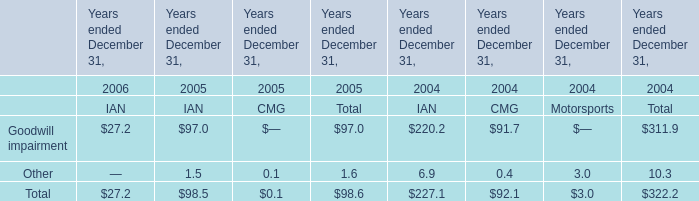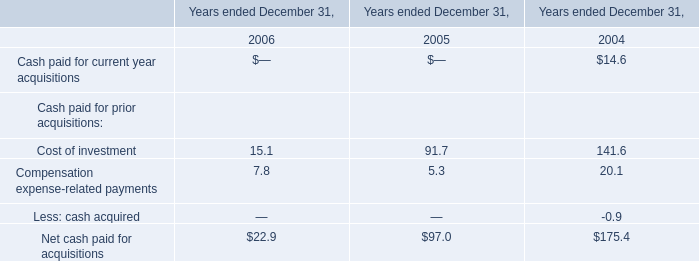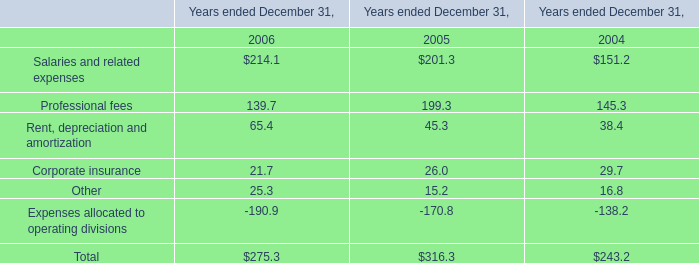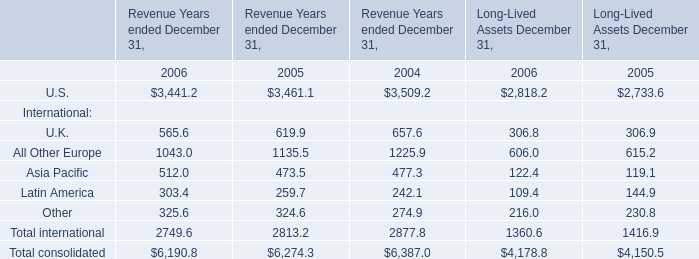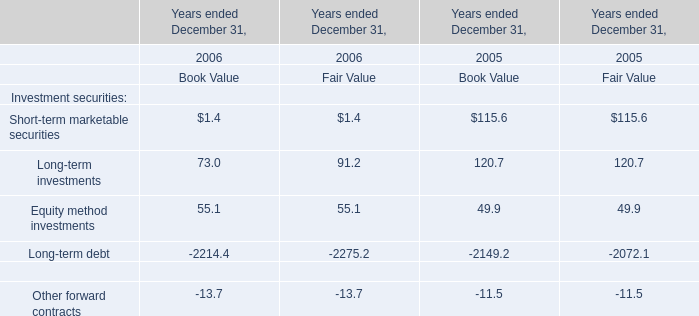Does the value of U.S. for Revenue Years ended December 31 in 2005 greater than that in 2004? 
Answer: No. 